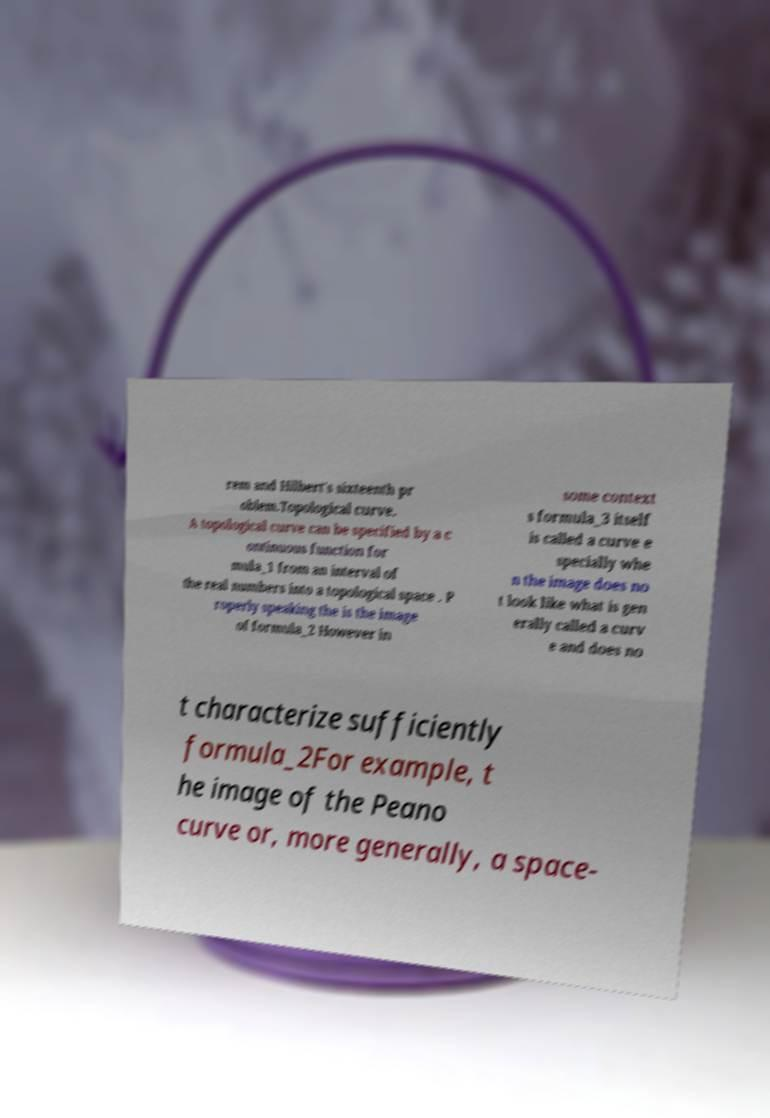I need the written content from this picture converted into text. Can you do that? rem and Hilbert's sixteenth pr oblem.Topological curve. A topological curve can be specified by a c ontinuous function for mula_1 from an interval of the real numbers into a topological space . P roperly speaking the is the image of formula_2 However in some context s formula_3 itself is called a curve e specially whe n the image does no t look like what is gen erally called a curv e and does no t characterize sufficiently formula_2For example, t he image of the Peano curve or, more generally, a space- 